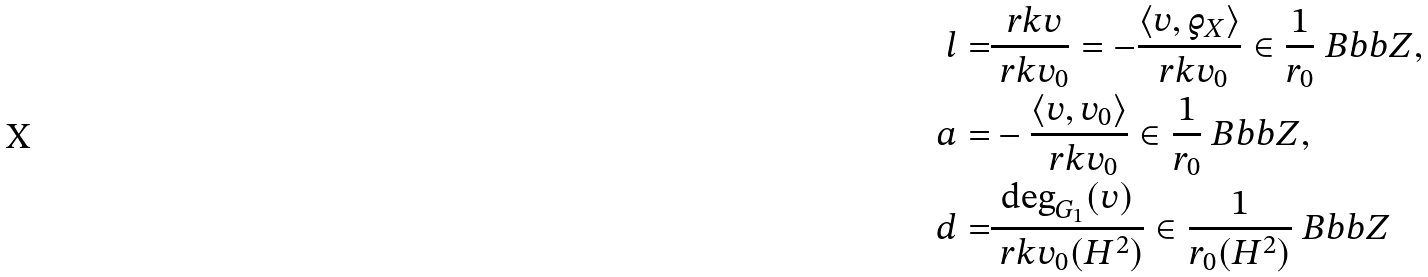<formula> <loc_0><loc_0><loc_500><loc_500>l = & \frac { \ r k v } { \ r k v _ { 0 } } = - \frac { \langle v , \varrho _ { X } \rangle } { \ r k v _ { 0 } } \in \frac { 1 } { r _ { 0 } } { \ B b b Z } , \\ a = & - \frac { \langle v , v _ { 0 } \rangle } { \ r k v _ { 0 } } \in \frac { 1 } { r _ { 0 } } { \ B b b Z } , \\ d = & \frac { \deg _ { G _ { 1 } } ( v ) } { \ r k v _ { 0 } ( H ^ { 2 } ) } \in \frac { 1 } { r _ { 0 } ( H ^ { 2 } ) } { \ B b b Z }</formula> 